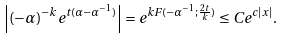<formula> <loc_0><loc_0><loc_500><loc_500>\left | ( - \alpha ) ^ { - k } e ^ { t ( \alpha - \alpha ^ { - 1 } ) } \right | = e ^ { k F ( - \alpha ^ { - 1 } ; \frac { 2 t } { k } ) } \leq C e ^ { c | x | } .</formula> 